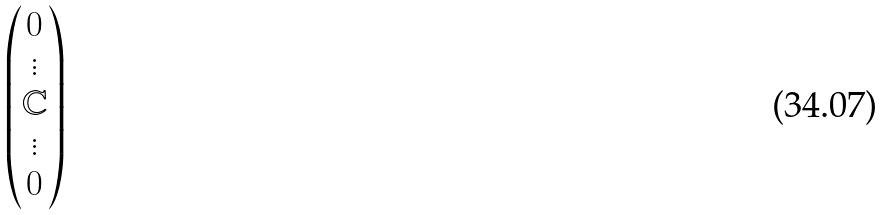<formula> <loc_0><loc_0><loc_500><loc_500>\begin{pmatrix} 0 \\ \vdots \\ \mathbb { C } \\ \vdots \\ 0 \end{pmatrix}</formula> 